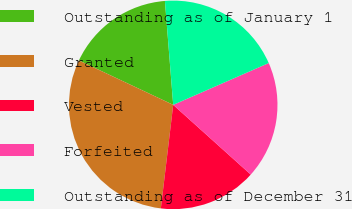Convert chart. <chart><loc_0><loc_0><loc_500><loc_500><pie_chart><fcel>Outstanding as of January 1<fcel>Granted<fcel>Vested<fcel>Forfeited<fcel>Outstanding as of December 31<nl><fcel>16.73%<fcel>30.11%<fcel>15.24%<fcel>18.22%<fcel>19.7%<nl></chart> 